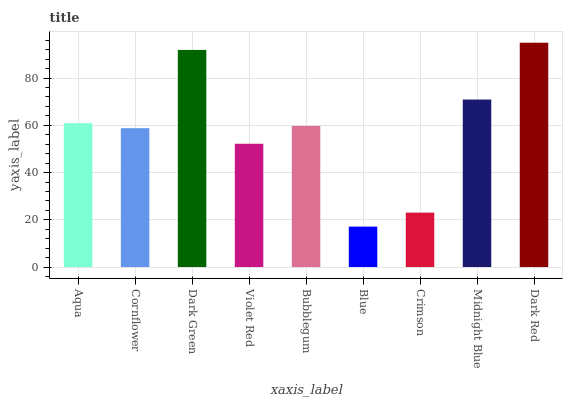Is Blue the minimum?
Answer yes or no. Yes. Is Dark Red the maximum?
Answer yes or no. Yes. Is Cornflower the minimum?
Answer yes or no. No. Is Cornflower the maximum?
Answer yes or no. No. Is Aqua greater than Cornflower?
Answer yes or no. Yes. Is Cornflower less than Aqua?
Answer yes or no. Yes. Is Cornflower greater than Aqua?
Answer yes or no. No. Is Aqua less than Cornflower?
Answer yes or no. No. Is Bubblegum the high median?
Answer yes or no. Yes. Is Bubblegum the low median?
Answer yes or no. Yes. Is Cornflower the high median?
Answer yes or no. No. Is Crimson the low median?
Answer yes or no. No. 